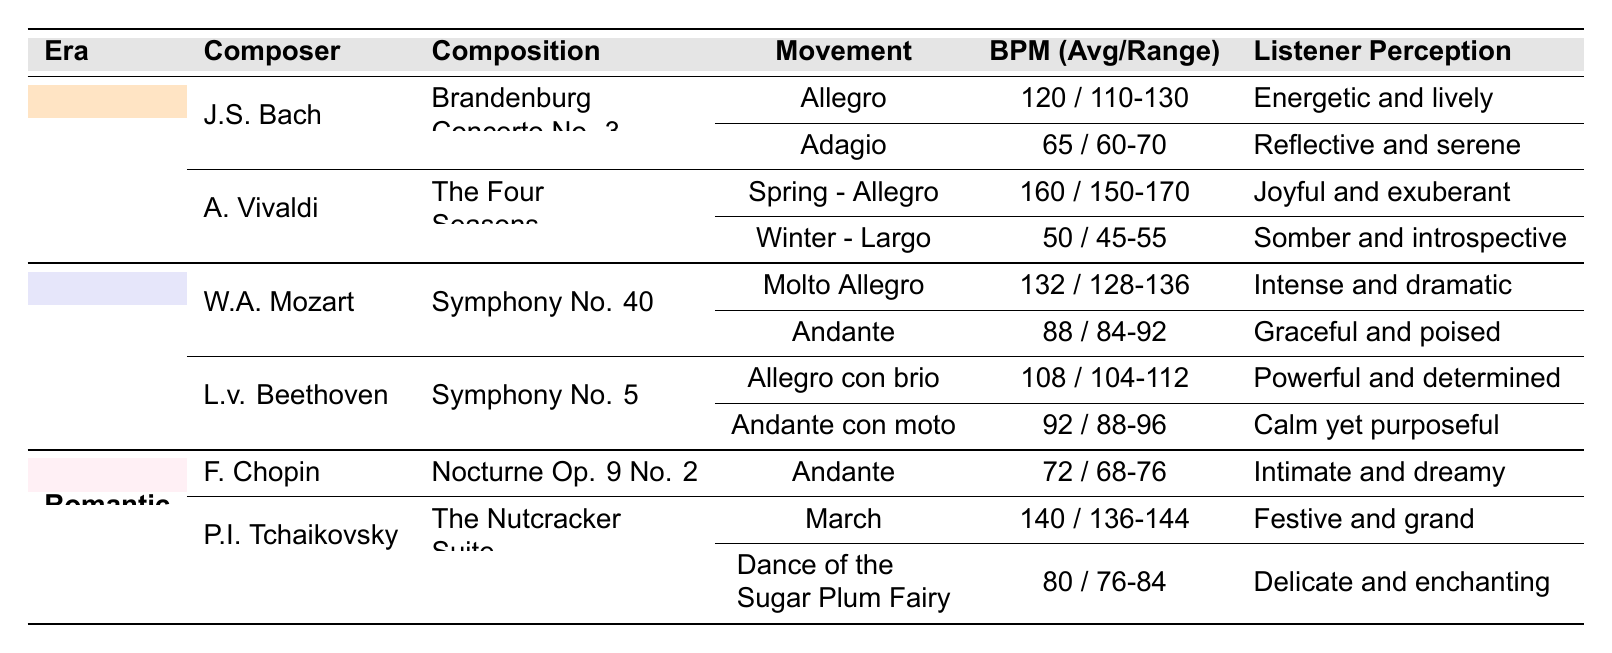What is the average BPM for "Allegro" in Bach's Brandenburg Concerto No. 3? The table shows that "Allegro" in Bach's composition has an average BPM of 120.
Answer: 120 Which composition by Vivaldi has the highest BPM? The table lists Vivaldi's "Spring - Allegro" with an average BPM of 160, which is the highest compared to "Winter - Largo" that has 50 BPM.
Answer: Spring - Allegro How many movements does Beethoven's Symphony No. 5 have listed in the table? The table shows two movements for Beethoven's Symphony No. 5: "Allegro con brio" and "Andante con moto."
Answer: 2 Is "Dance of the Sugar Plum Fairy" faster than "Adagio" from Bach's Brandenburg Concerto No. 3? The average BPM for "Dance of the Sugar Plum Fairy" is 80, while "Adagio" has an average BPM of 65, so yes, it is faster.
Answer: Yes What is the total BPM range of the two movements in Vivaldi's composition? The BPM ranges are "150-170" for "Spring - Allegro" and "45-55" for "Winter - Largo." The total of both ranges is 170 - 45 = 125.
Answer: 125 Which composer has a composition with a listener perception described as "intimate and dreamy"? The table states that Frédéric Chopin's "Nocturne Op. 9 No. 2" has a listener perception of "intimate and dreamy."
Answer: Frédéric Chopin On average, how much faster is "Molto Allegro" in Mozart's Symphony No. 40 compared to "Adagio" in Bach's Brandenburg Concerto No. 3? "Molto Allegro" has an average BPM of 132, while "Adagio" has 65. The difference is 132 - 65 = 67 BPM.
Answer: 67 BPM What is the BPM range for "March" from Tchaikovsky's The Nutcracker Suite? The table lists the BPM range for "March" as "136-144."
Answer: 136-144 Are there any compositions in the Romantic era with an average BPM above 100? Yes, Tchaikovsky's "March" has an average BPM of 140, which is above 100.
Answer: Yes Which era boasts compositions with an average BPM below 70? The table shows that both "Adagio" in Bach's Brandenburg Concerto No. 3 and "Winter - Largo" in Vivaldi's Four Seasons have average BPMs below 70, indicating that the Baroque era contains such compositions.
Answer: Baroque 